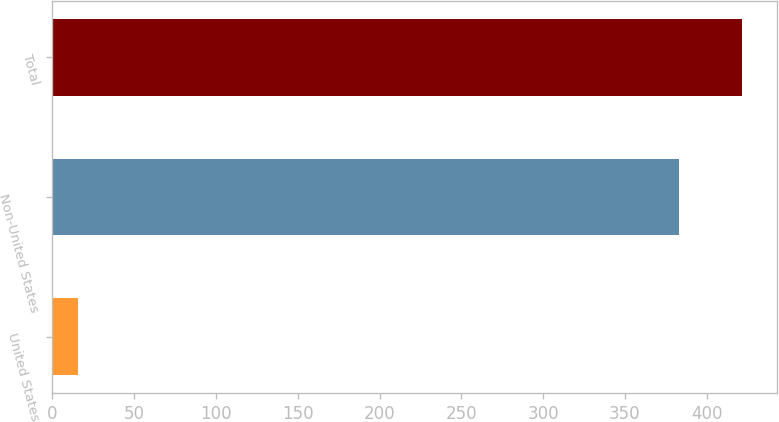<chart> <loc_0><loc_0><loc_500><loc_500><bar_chart><fcel>United States<fcel>Non-United States<fcel>Total<nl><fcel>15.7<fcel>383.3<fcel>421.63<nl></chart> 